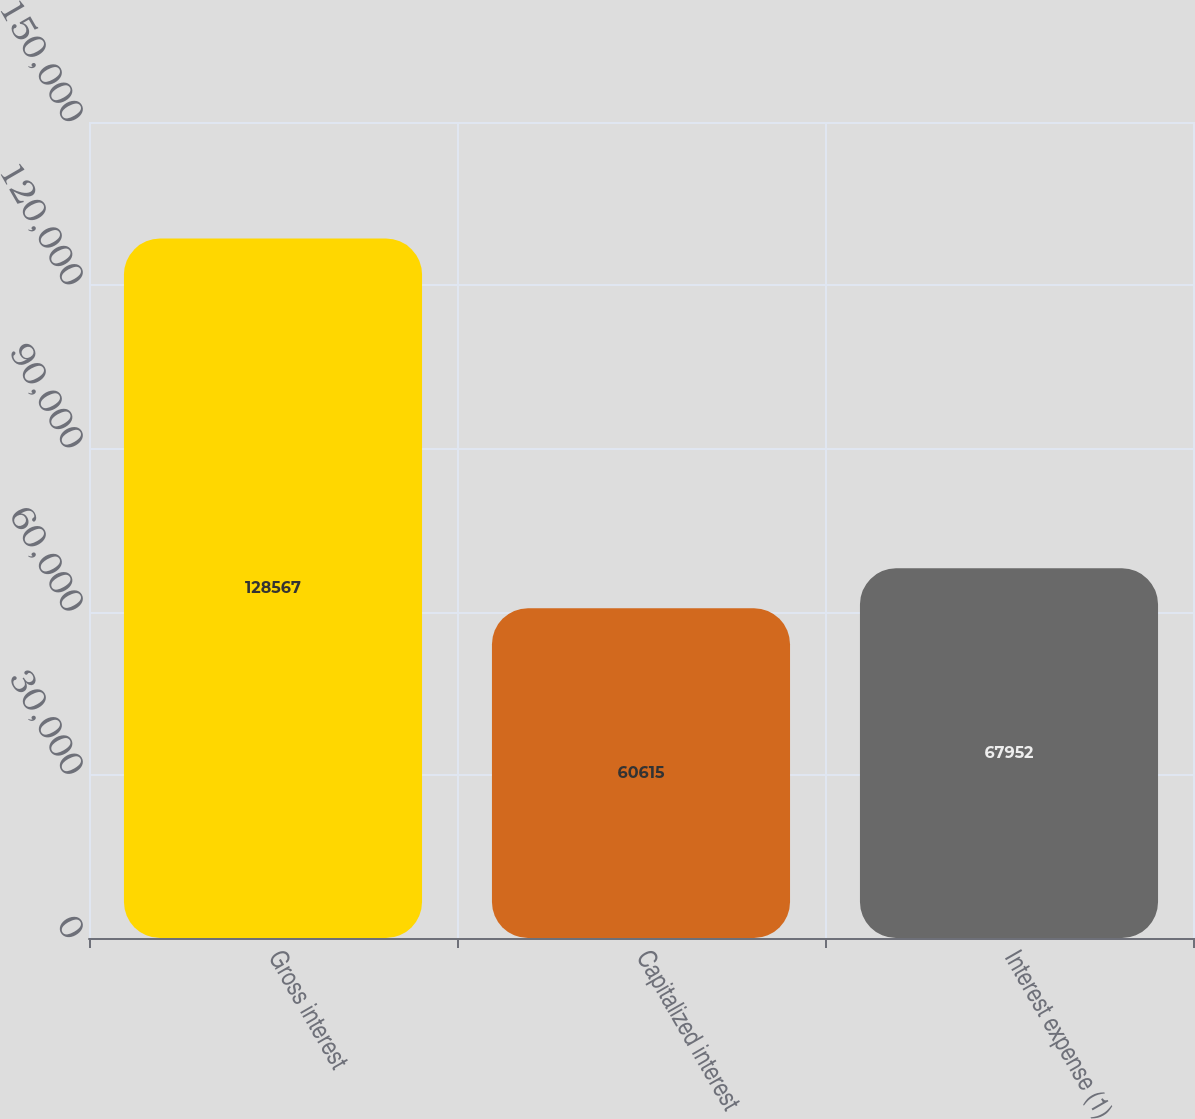<chart> <loc_0><loc_0><loc_500><loc_500><bar_chart><fcel>Gross interest<fcel>Capitalized interest<fcel>Interest expense (1)<nl><fcel>128567<fcel>60615<fcel>67952<nl></chart> 